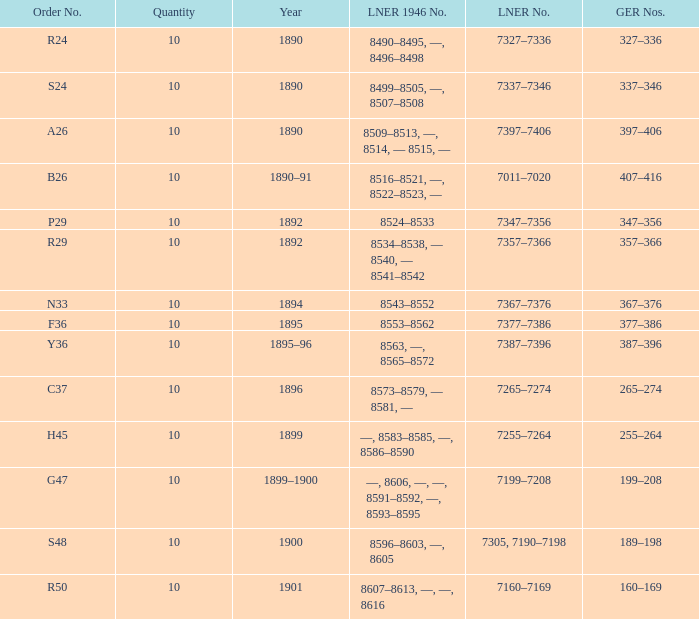What is order S24's LNER 1946 number? 8499–8505, —, 8507–8508. 